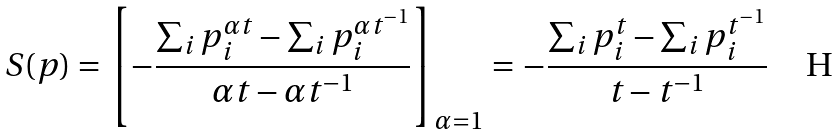Convert formula to latex. <formula><loc_0><loc_0><loc_500><loc_500>S ( p ) = \left [ - \frac { \sum _ { i } p ^ { \alpha t } _ { i } - \sum _ { i } p ^ { \alpha t ^ { - 1 } } _ { i } } { \alpha t - \alpha t ^ { - 1 } } \right ] _ { \alpha = 1 } = - \frac { \sum _ { i } p ^ { t } _ { i } - \sum _ { i } p ^ { t ^ { - 1 } } _ { i } } { t - t ^ { - 1 } }</formula> 